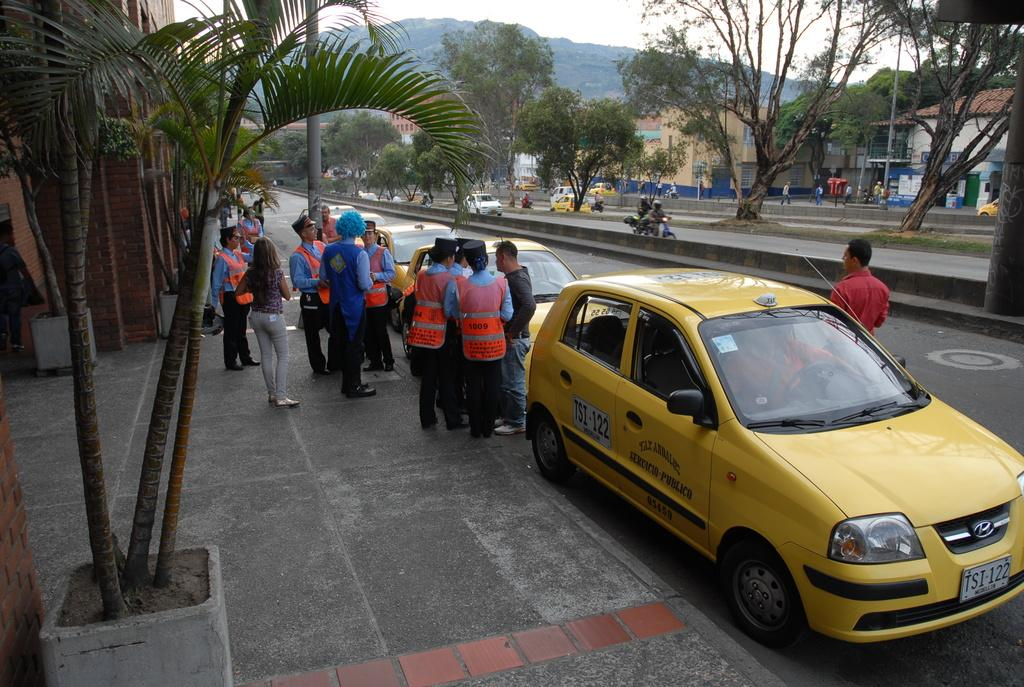<image>
Render a clear and concise summary of the photo. Yellow tax with the call signs TSI-122 in front of a building. 